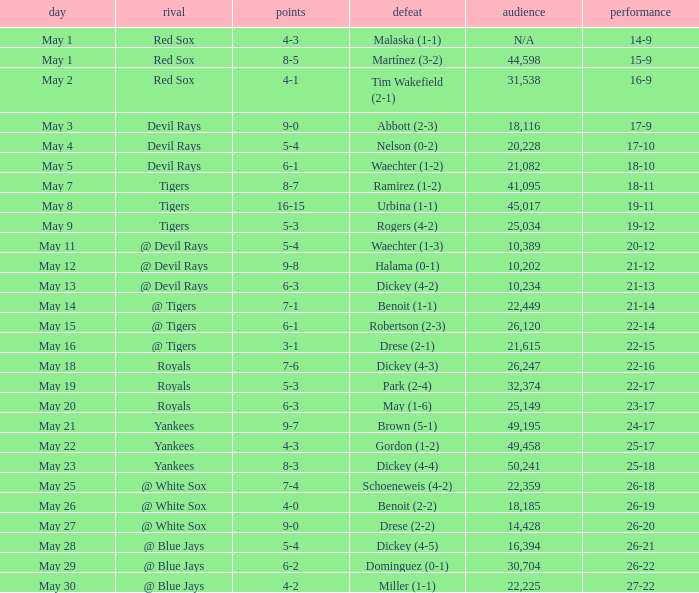What is the score of the game attended by 25,034? 5-3. 